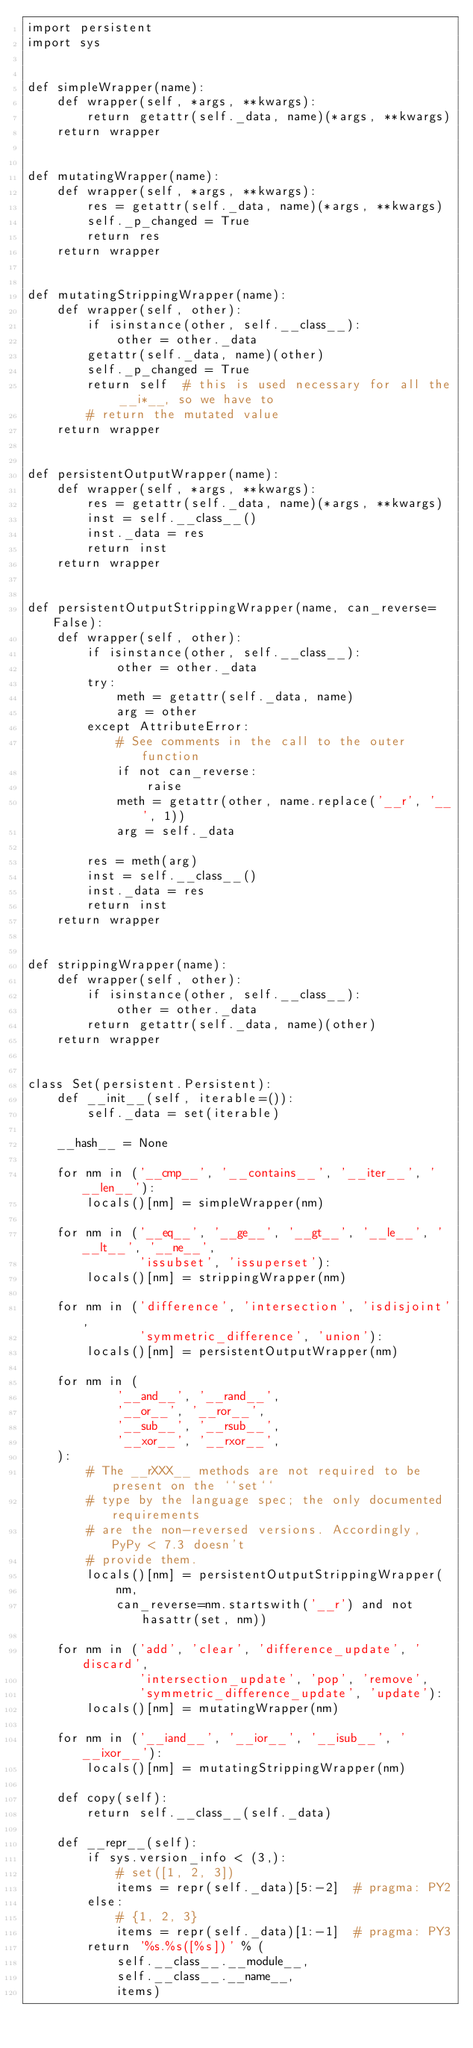Convert code to text. <code><loc_0><loc_0><loc_500><loc_500><_Python_>import persistent
import sys


def simpleWrapper(name):
    def wrapper(self, *args, **kwargs):
        return getattr(self._data, name)(*args, **kwargs)
    return wrapper


def mutatingWrapper(name):
    def wrapper(self, *args, **kwargs):
        res = getattr(self._data, name)(*args, **kwargs)
        self._p_changed = True
        return res
    return wrapper


def mutatingStrippingWrapper(name):
    def wrapper(self, other):
        if isinstance(other, self.__class__):
            other = other._data
        getattr(self._data, name)(other)
        self._p_changed = True
        return self  # this is used necessary for all the __i*__, so we have to
        # return the mutated value
    return wrapper


def persistentOutputWrapper(name):
    def wrapper(self, *args, **kwargs):
        res = getattr(self._data, name)(*args, **kwargs)
        inst = self.__class__()
        inst._data = res
        return inst
    return wrapper


def persistentOutputStrippingWrapper(name, can_reverse=False):
    def wrapper(self, other):
        if isinstance(other, self.__class__):
            other = other._data
        try:
            meth = getattr(self._data, name)
            arg = other
        except AttributeError:
            # See comments in the call to the outer function
            if not can_reverse:
                raise
            meth = getattr(other, name.replace('__r', '__', 1))
            arg = self._data

        res = meth(arg)
        inst = self.__class__()
        inst._data = res
        return inst
    return wrapper


def strippingWrapper(name):
    def wrapper(self, other):
        if isinstance(other, self.__class__):
            other = other._data
        return getattr(self._data, name)(other)
    return wrapper


class Set(persistent.Persistent):
    def __init__(self, iterable=()):
        self._data = set(iterable)

    __hash__ = None

    for nm in ('__cmp__', '__contains__', '__iter__', '__len__'):
        locals()[nm] = simpleWrapper(nm)

    for nm in ('__eq__', '__ge__', '__gt__', '__le__', '__lt__', '__ne__',
               'issubset', 'issuperset'):
        locals()[nm] = strippingWrapper(nm)

    for nm in ('difference', 'intersection', 'isdisjoint',
               'symmetric_difference', 'union'):
        locals()[nm] = persistentOutputWrapper(nm)

    for nm in (
            '__and__', '__rand__',
            '__or__', '__ror__',
            '__sub__', '__rsub__',
            '__xor__', '__rxor__',
    ):
        # The __rXXX__ methods are not required to be present on the ``set``
        # type by the language spec; the only documented requirements
        # are the non-reversed versions. Accordingly, PyPy < 7.3 doesn't
        # provide them.
        locals()[nm] = persistentOutputStrippingWrapper(
            nm,
            can_reverse=nm.startswith('__r') and not hasattr(set, nm))

    for nm in ('add', 'clear', 'difference_update', 'discard',
               'intersection_update', 'pop', 'remove',
               'symmetric_difference_update', 'update'):
        locals()[nm] = mutatingWrapper(nm)

    for nm in ('__iand__', '__ior__', '__isub__', '__ixor__'):
        locals()[nm] = mutatingStrippingWrapper(nm)

    def copy(self):
        return self.__class__(self._data)

    def __repr__(self):
        if sys.version_info < (3,):
            # set([1, 2, 3])
            items = repr(self._data)[5:-2]  # pragma: PY2
        else:
            # {1, 2, 3}
            items = repr(self._data)[1:-1]  # pragma: PY3
        return '%s.%s([%s])' % (
            self.__class__.__module__,
            self.__class__.__name__,
            items)
</code> 